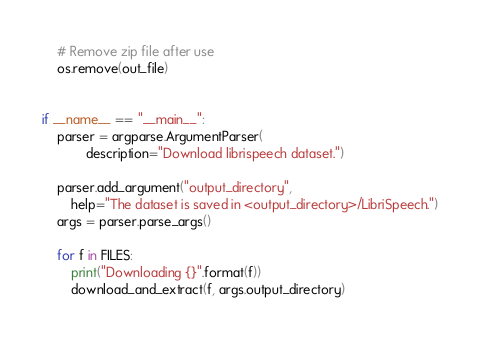Convert code to text. <code><loc_0><loc_0><loc_500><loc_500><_Python_>    # Remove zip file after use
    os.remove(out_file)


if __name__ == "__main__":
    parser = argparse.ArgumentParser(
            description="Download librispeech dataset.")

    parser.add_argument("output_directory",
        help="The dataset is saved in <output_directory>/LibriSpeech.")
    args = parser.parse_args()

    for f in FILES:
        print("Downloading {}".format(f))
        download_and_extract(f, args.output_directory)
</code> 